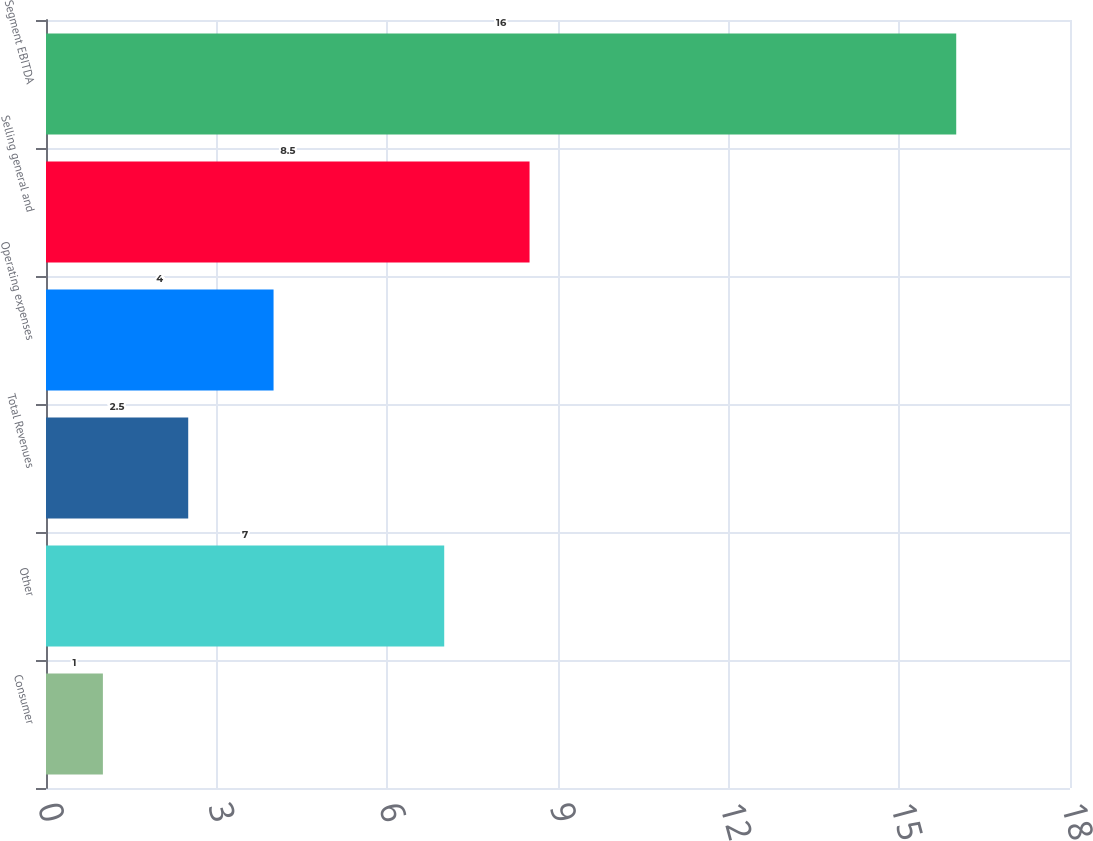Convert chart to OTSL. <chart><loc_0><loc_0><loc_500><loc_500><bar_chart><fcel>Consumer<fcel>Other<fcel>Total Revenues<fcel>Operating expenses<fcel>Selling general and<fcel>Segment EBITDA<nl><fcel>1<fcel>7<fcel>2.5<fcel>4<fcel>8.5<fcel>16<nl></chart> 